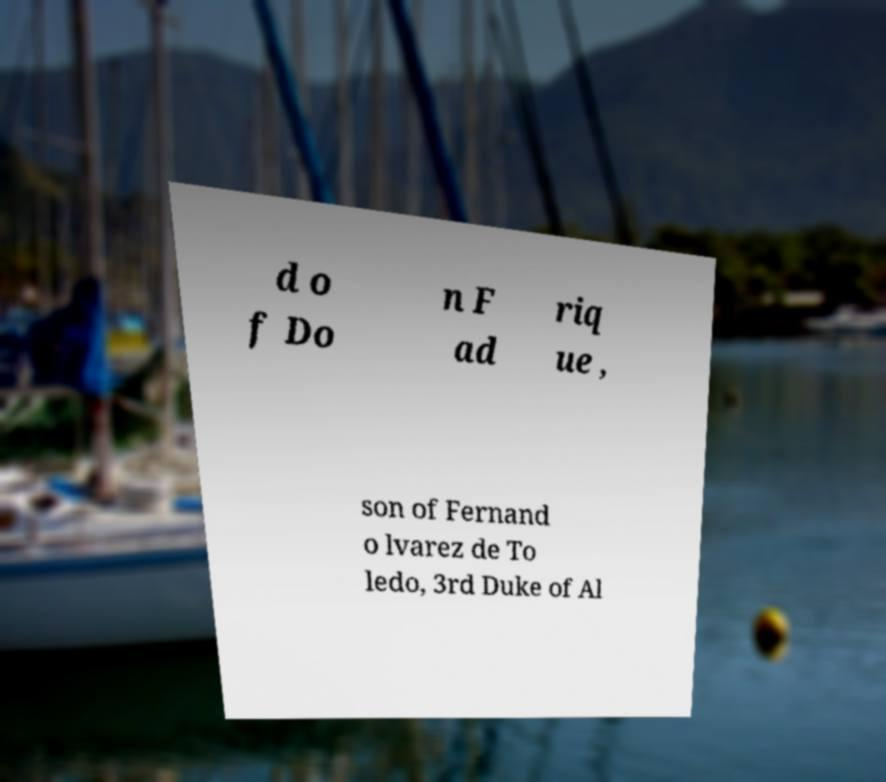Could you assist in decoding the text presented in this image and type it out clearly? d o f Do n F ad riq ue , son of Fernand o lvarez de To ledo, 3rd Duke of Al 